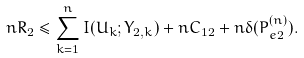Convert formula to latex. <formula><loc_0><loc_0><loc_500><loc_500>n R _ { 2 } \leq \sum _ { k = 1 } ^ { n } I ( U _ { k } ; Y _ { 2 , k } ) + n C _ { 1 2 } + n \delta ( P _ { e 2 } ^ { ( n ) } ) .</formula> 